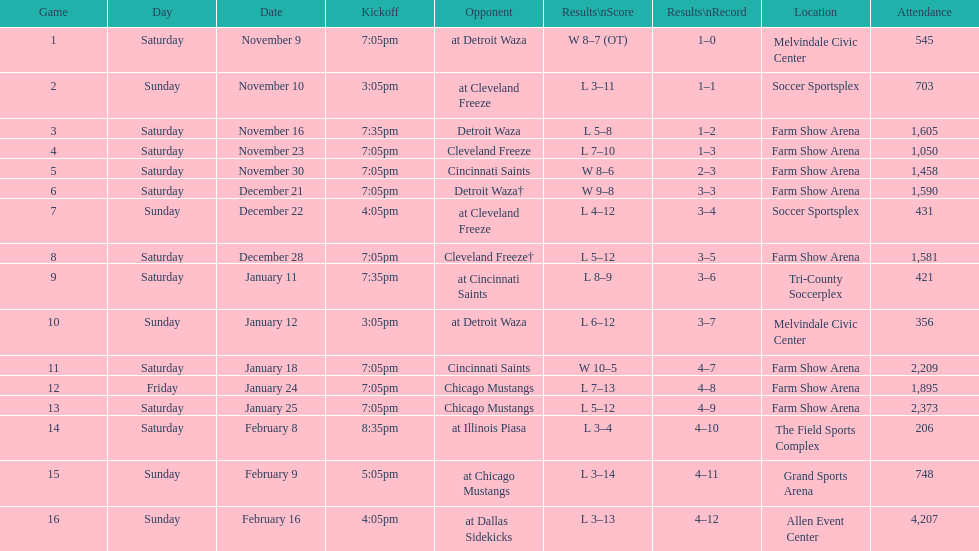What was the duration of the team's lengthiest losing streak? 5 games. 